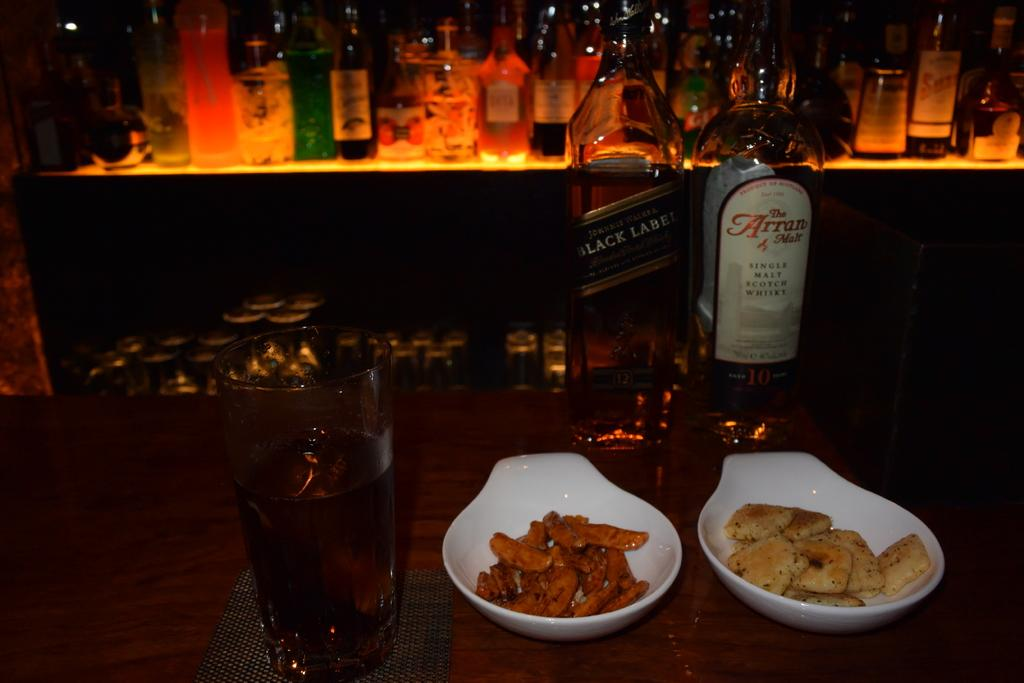<image>
Share a concise interpretation of the image provided. A bottle of The Arran Malt next to a bottle of Black Label and some snacks on a bar. 